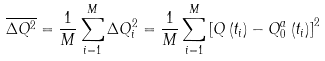Convert formula to latex. <formula><loc_0><loc_0><loc_500><loc_500>\overline { \Delta Q ^ { 2 } } = \frac { 1 } { M } \sum _ { i = 1 } ^ { M } \Delta Q _ { i } ^ { 2 } = \frac { 1 } { M } \sum _ { i = 1 } ^ { M } \left [ Q \left ( t _ { i } \right ) - Q _ { 0 } ^ { a } \left ( t _ { i } \right ) \right ] ^ { 2 }</formula> 